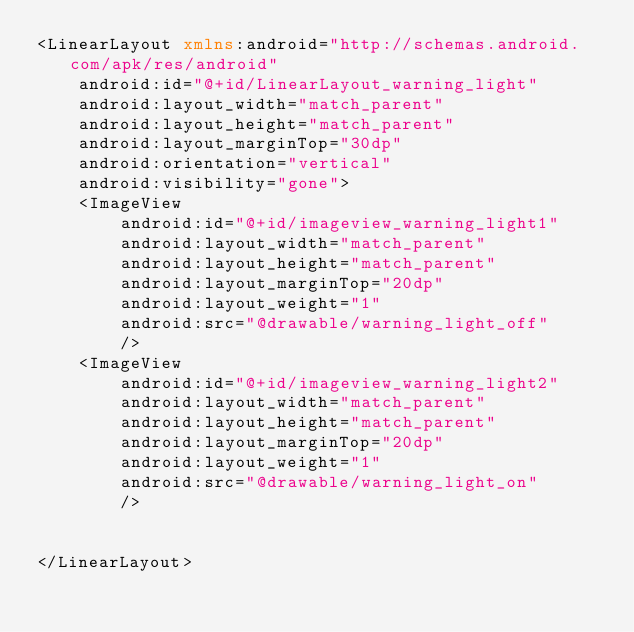<code> <loc_0><loc_0><loc_500><loc_500><_XML_><LinearLayout xmlns:android="http://schemas.android.com/apk/res/android"
    android:id="@+id/LinearLayout_warning_light"
    android:layout_width="match_parent"
    android:layout_height="match_parent"
    android:layout_marginTop="30dp"
    android:orientation="vertical"
    android:visibility="gone">
    <ImageView
        android:id="@+id/imageview_warning_light1"
        android:layout_width="match_parent"
        android:layout_height="match_parent"
        android:layout_marginTop="20dp"
        android:layout_weight="1"
        android:src="@drawable/warning_light_off"
        />
    <ImageView
        android:id="@+id/imageview_warning_light2"
        android:layout_width="match_parent"
        android:layout_height="match_parent"
        android:layout_marginTop="20dp"
        android:layout_weight="1"
        android:src="@drawable/warning_light_on"
        />


</LinearLayout></code> 